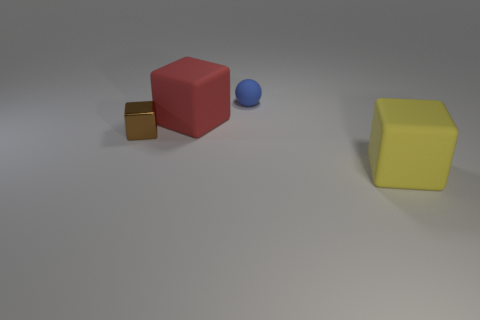Subtract all yellow matte cubes. How many cubes are left? 2 Add 2 large cyan rubber blocks. How many objects exist? 6 Subtract 0 green cylinders. How many objects are left? 4 Subtract all balls. How many objects are left? 3 Subtract 1 spheres. How many spheres are left? 0 Subtract all purple blocks. Subtract all brown cylinders. How many blocks are left? 3 Subtract all green cylinders. How many blue cubes are left? 0 Subtract all brown things. Subtract all tiny blue objects. How many objects are left? 2 Add 4 tiny matte things. How many tiny matte things are left? 5 Add 2 yellow things. How many yellow things exist? 3 